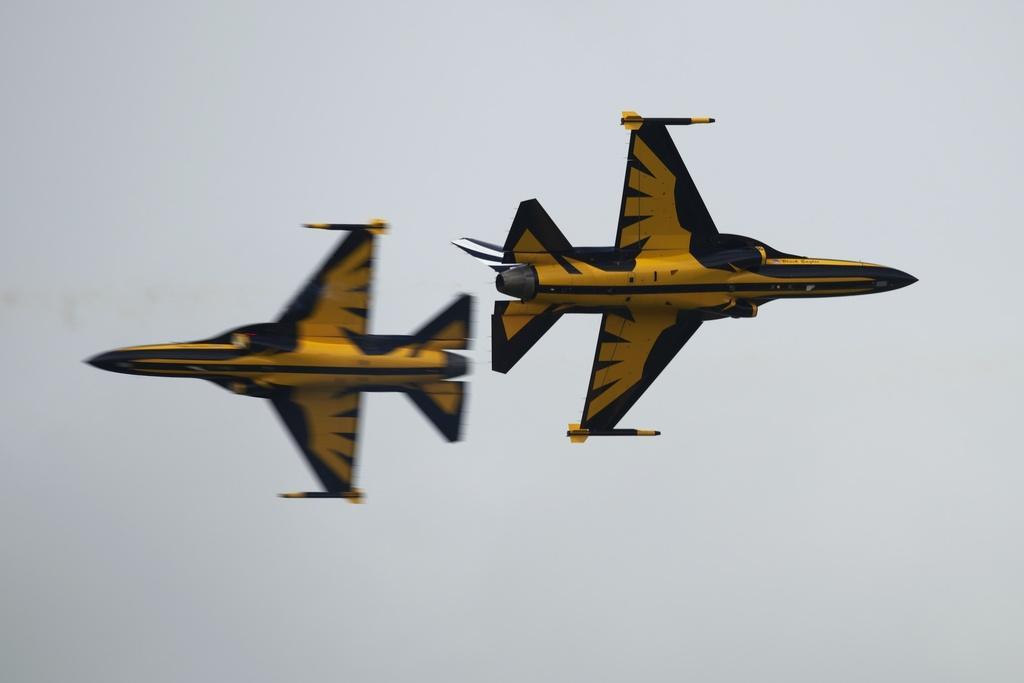Can you describe this image briefly? In this image I can see two aeroplanes. They are in yellow and black color. Background is in white color. 